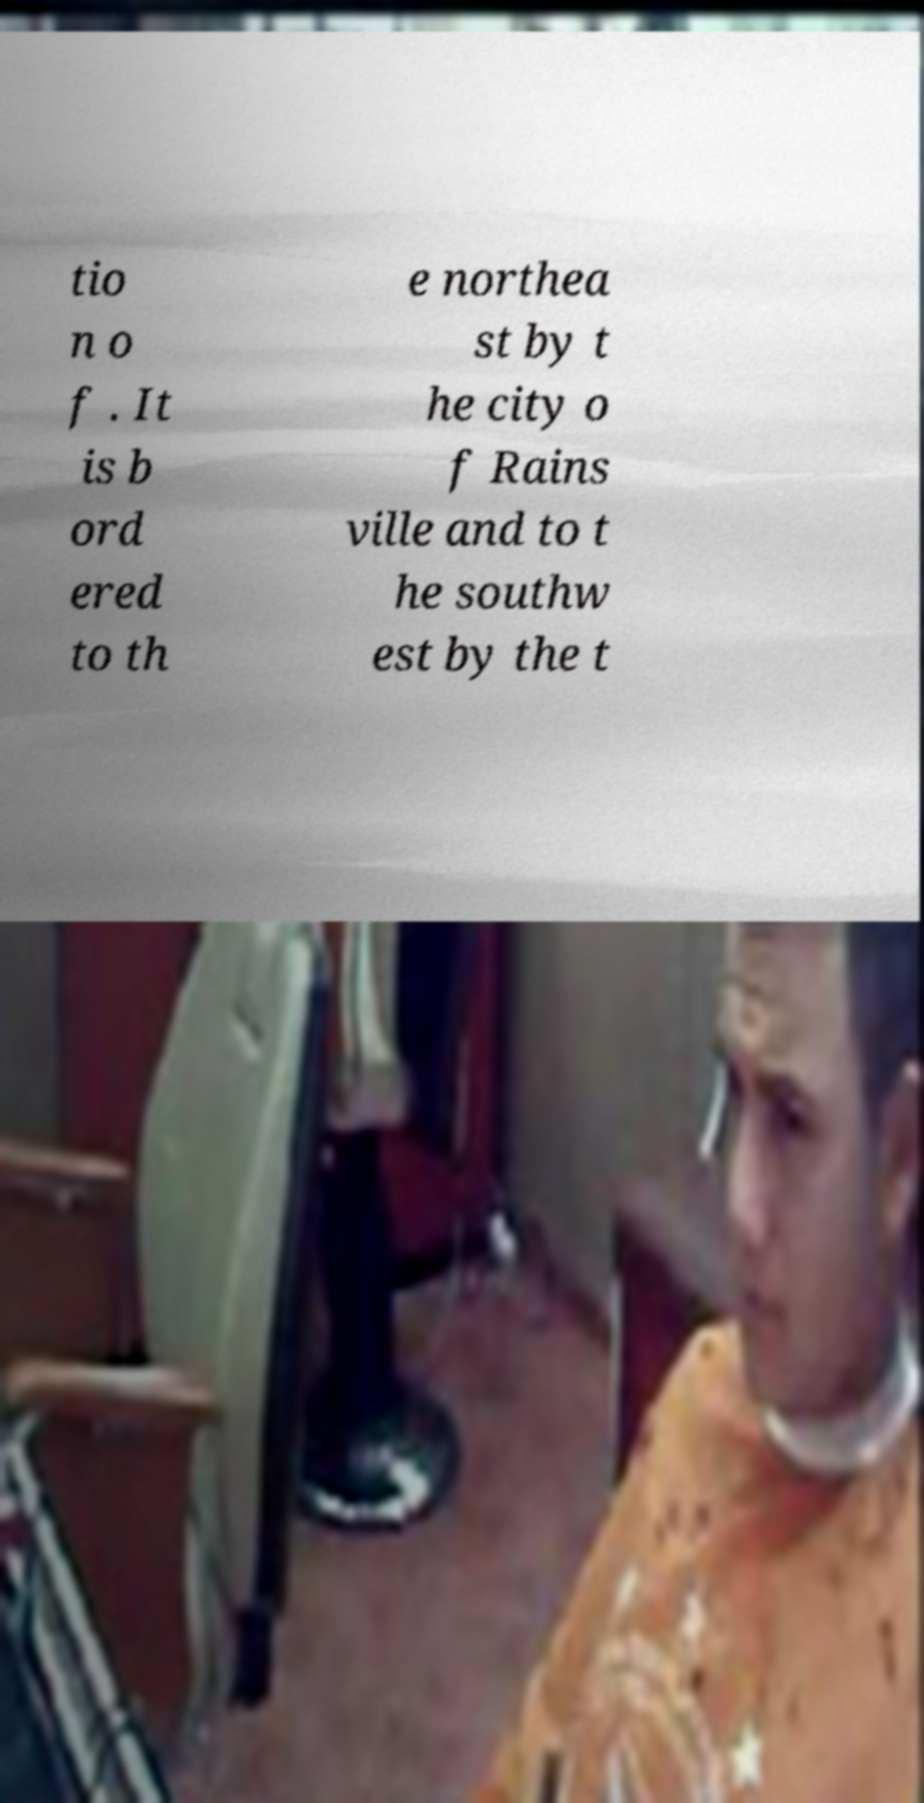Please read and relay the text visible in this image. What does it say? tio n o f . It is b ord ered to th e northea st by t he city o f Rains ville and to t he southw est by the t 